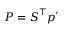Convert formula to latex. <formula><loc_0><loc_0><loc_500><loc_500>P = S ^ { \intercal } p ^ { \prime }</formula> 